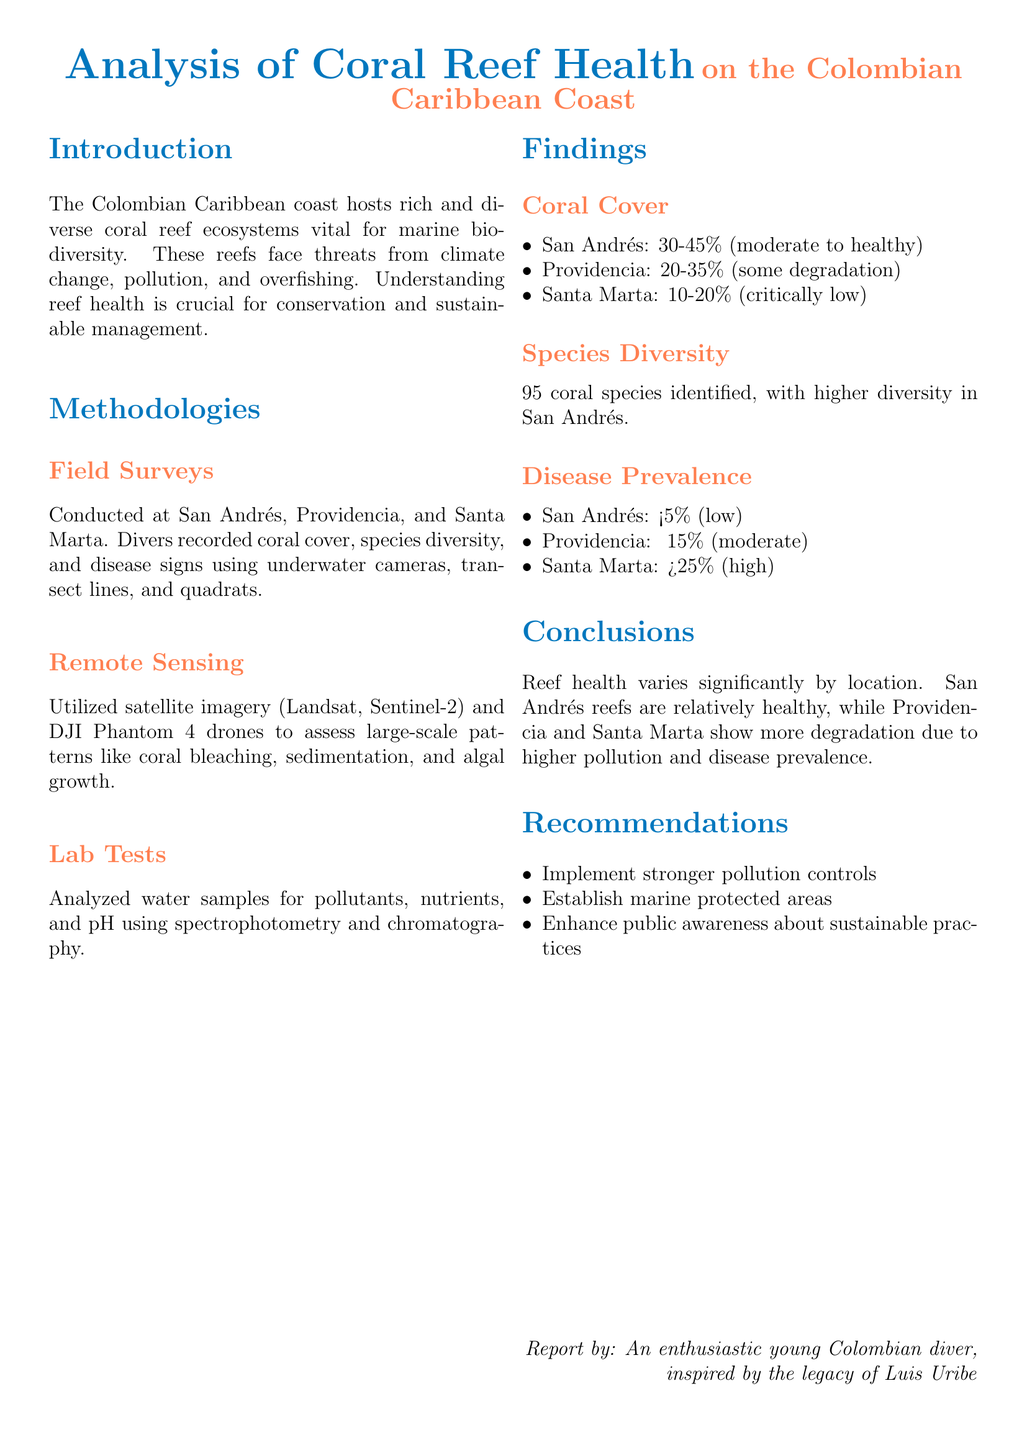What is the health status of coral cover in San Andrés? The health status of coral cover in San Andrés is recorded as 30-45%, which indicates moderate to healthy conditions.
Answer: 30-45% Which location had the lowest species diversity? The document states that Santa Marta had the lowest species diversity compared to the other surveyed locations.
Answer: Santa Marta What percentage of disease prevalence was observed in Providencia? The report mentions a disease prevalence of approximately 15% in Providencia, indicating moderate levels of disease.
Answer: ~15% What technology was used for remote sensing? Remote sensing utilized satellite imagery from Landsat and Sentinel-2 along with DJI Phantom 4 drones, as specified in the methodologies.
Answer: Satellites and drones What were the recommendations after the findings of the study? The recommendations included implementing stronger pollution controls, establishing marine protected areas, and enhancing public awareness about sustainable practices.
Answer: Stronger pollution controls In which location were higher coral species diversity identified? Higher coral species diversity was identified in San Andrés, as highlighted in the findings section of the report.
Answer: San Andrés What is the highest percentage of coral cover reported? The highest percentage of coral cover reported is 45%, which was observed in San Andrés.
Answer: 45% What lab techniques were used to analyze water samples? The lab techniques used included spectrophotometry and chromatography, as outlined in the methodologies section.
Answer: Spectrophotometry and chromatography 